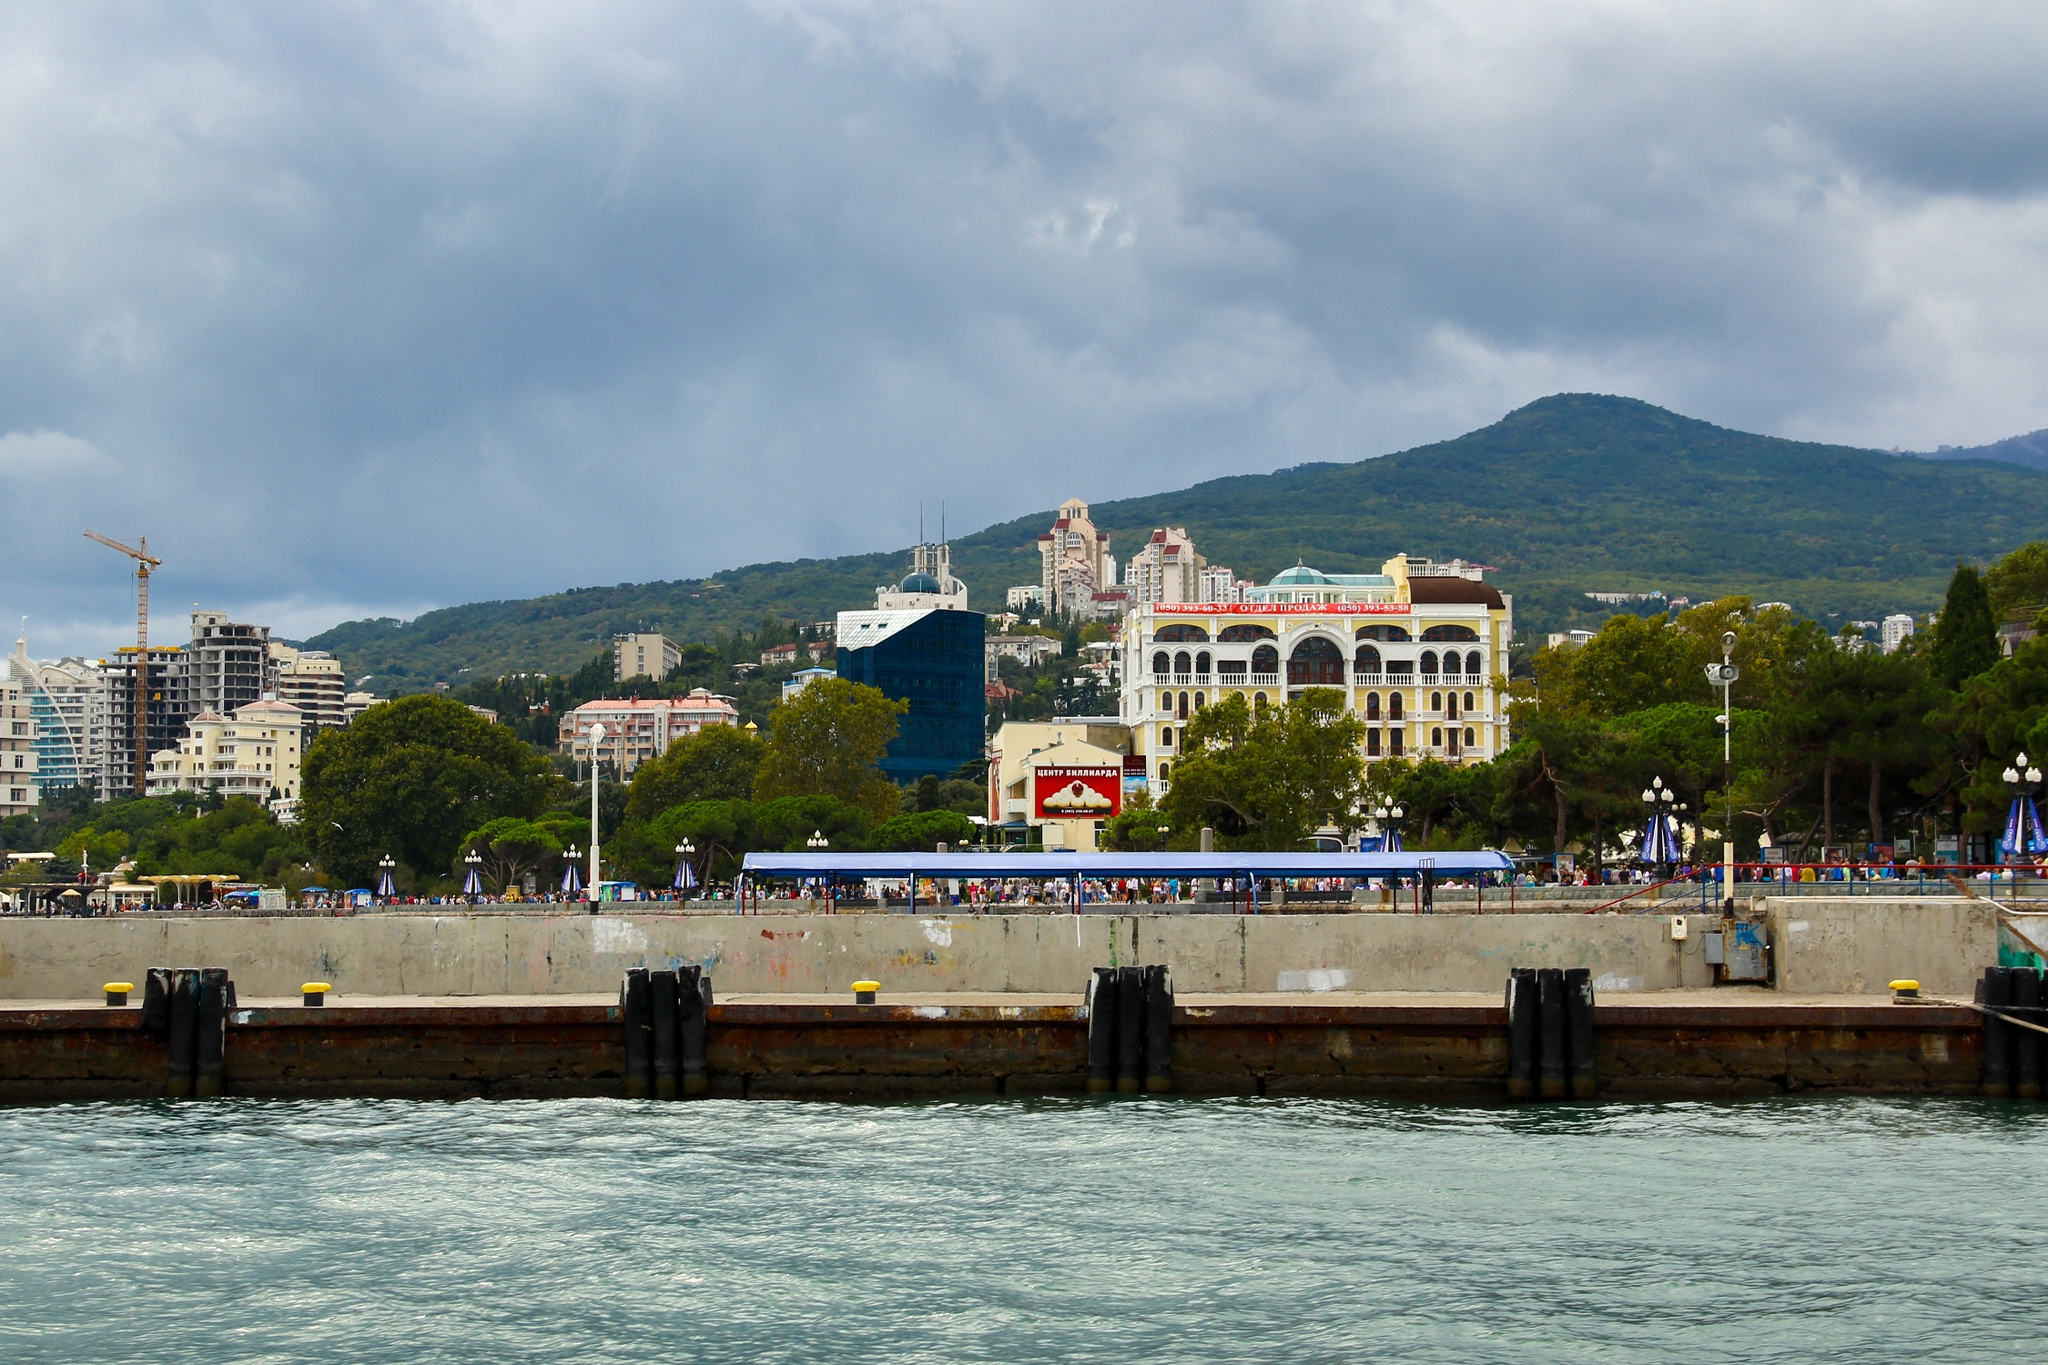Describe the following image. The image showcases the vibrant and scenic Yalta seafront in Crimea. The vantage point is from the water, directing the viewer's gaze towards the shore. A concrete pier lines the shoreline, bustling with people, adding to the area's lively atmosphere. This vibrant promenade is backed by a variety of architectural styles, including a prominent white building with a red roof and another distinctive blue building with a green roof. Behind them, the verdant hills provide a picturesque backdrop. The cloudy sky casts a soft light over the scene, while the deep blue water provides a vibrant contrast, reflecting the dynamism and charm of this beautiful coastal spot. 